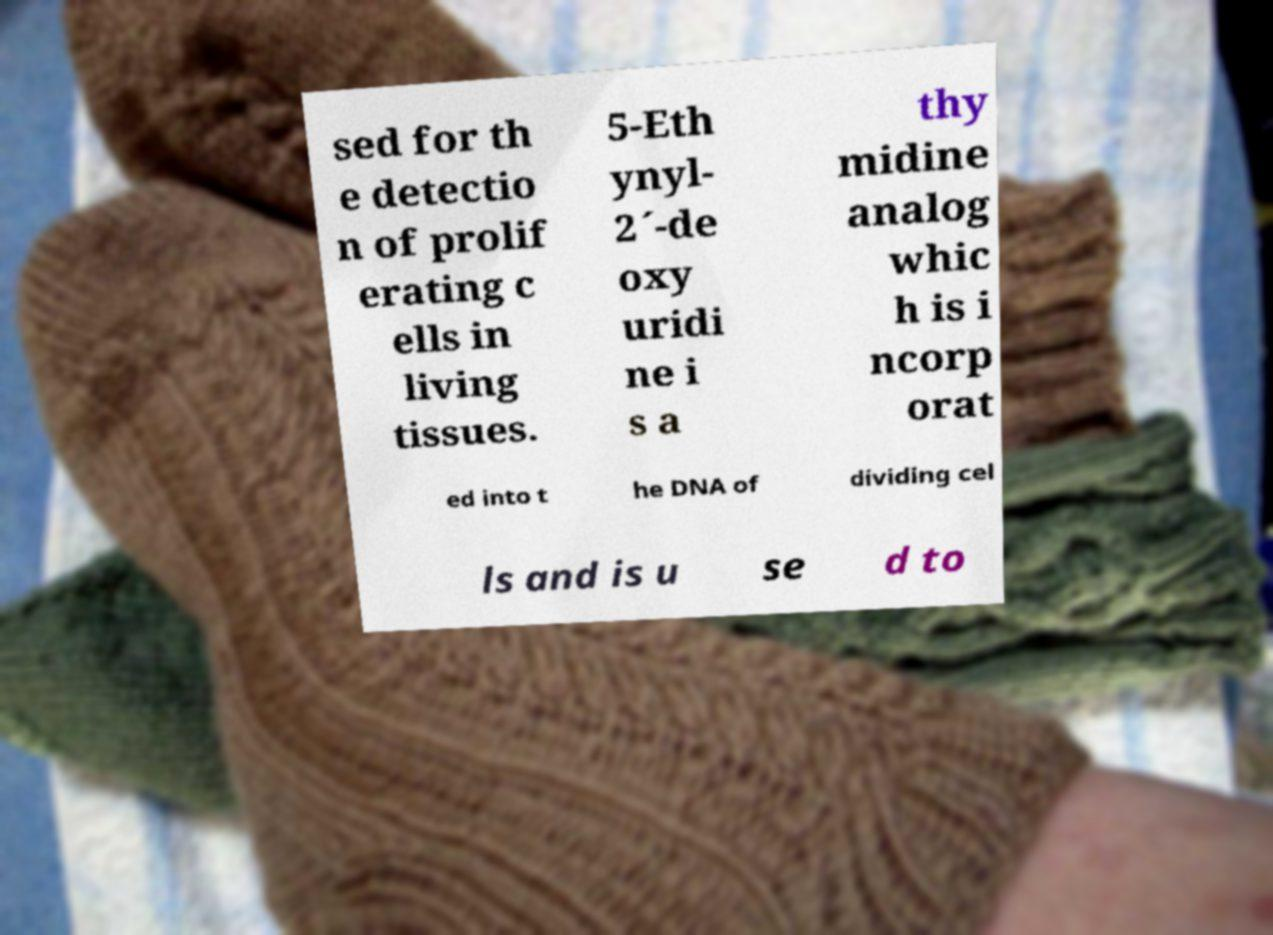Please read and relay the text visible in this image. What does it say? sed for th e detectio n of prolif erating c ells in living tissues. 5-Eth ynyl- 2´-de oxy uridi ne i s a thy midine analog whic h is i ncorp orat ed into t he DNA of dividing cel ls and is u se d to 